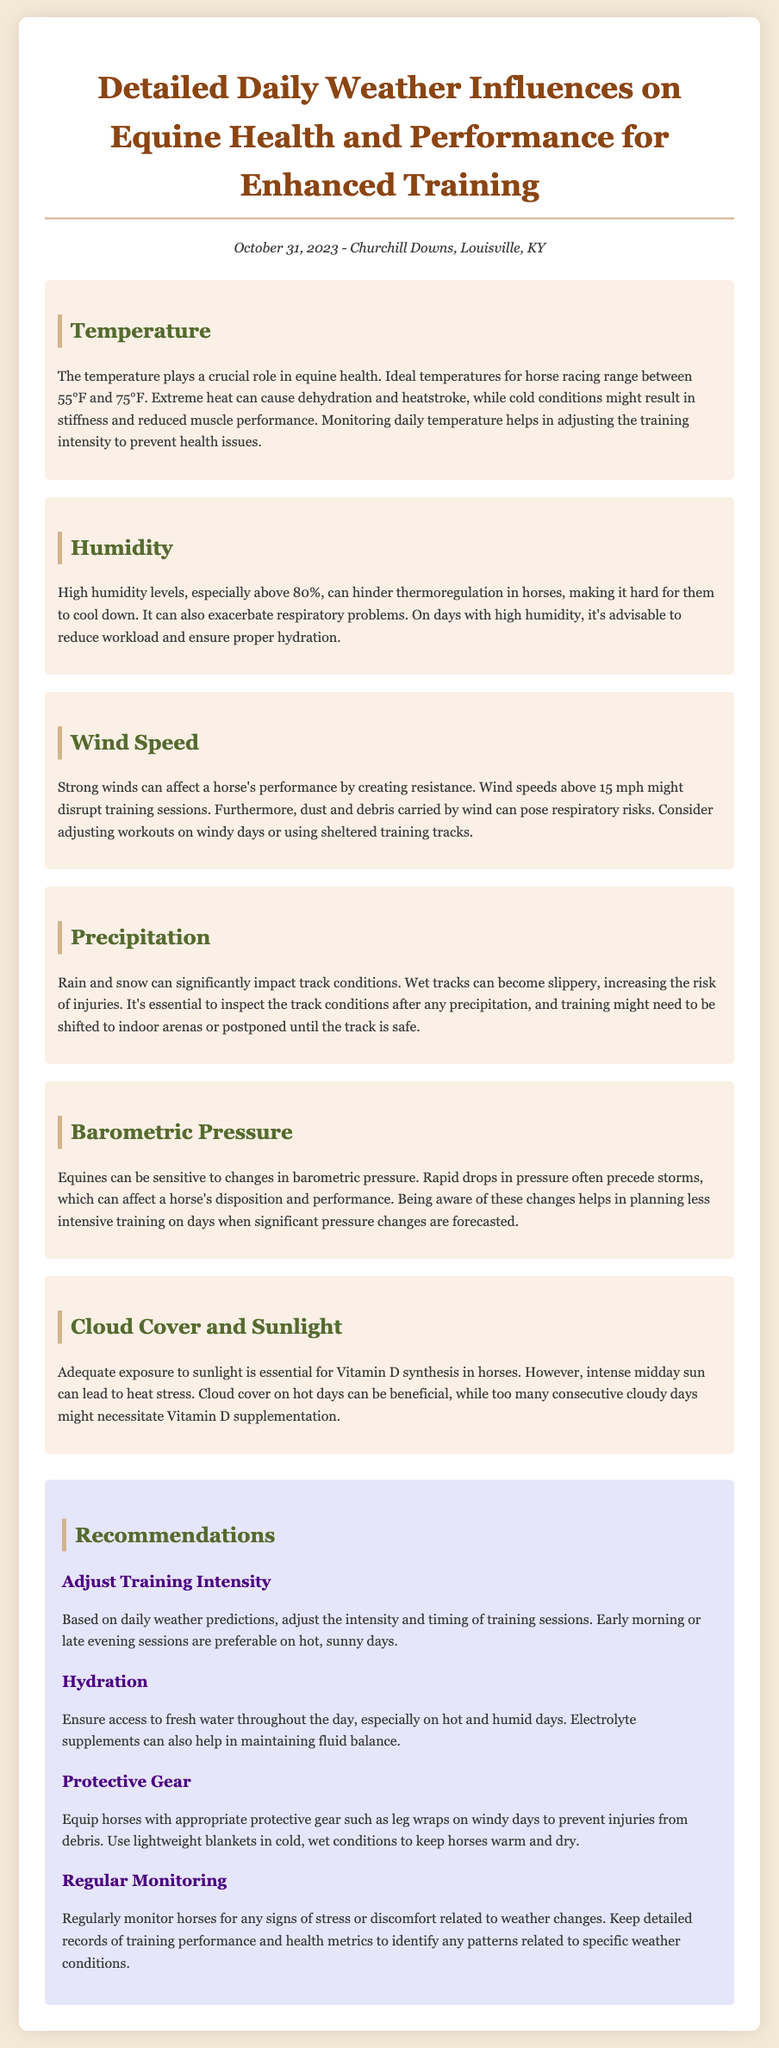What is the ideal temperature range for horse racing? The document states that ideal temperatures for horse racing range between 55°F and 75°F.
Answer: 55°F to 75°F What humidity level should be considered problematic for horses? According to the report, high humidity levels, especially above 80%, can hinder thermoregulation in horses.
Answer: Above 80% What wind speed might disrupt training sessions? The report mentions that wind speeds above 15 mph might disrupt training sessions.
Answer: 15 mph What action should be taken on days with heavy precipitation? The document recommends inspecting the track conditions after any precipitation and possibly shifting training to indoor arenas.
Answer: Shift to indoor arenas What should be monitored for changes due to barometric pressure? The report suggests monitoring horses for disposition and performance, which can be affected by rapid drops in barometric pressure.
Answer: Disposition and performance On hot, sunny days, what is a preferable training time? The document recommends early morning or late evening sessions on hot, sunny days.
Answer: Early morning or late evening How can hydration be maintained effectively? The report states to ensure access to fresh water throughout the day, especially on hot and humid days.
Answer: Access to fresh water What protective gear should be used on windy days? The document specifies equipping horses with leg wraps on windy days to prevent injuries from debris.
Answer: Leg wraps Why is adequate exposure to sunlight important for horses? The report highlights that adequate exposure to sunlight is essential for Vitamin D synthesis in horses.
Answer: Vitamin D synthesis 